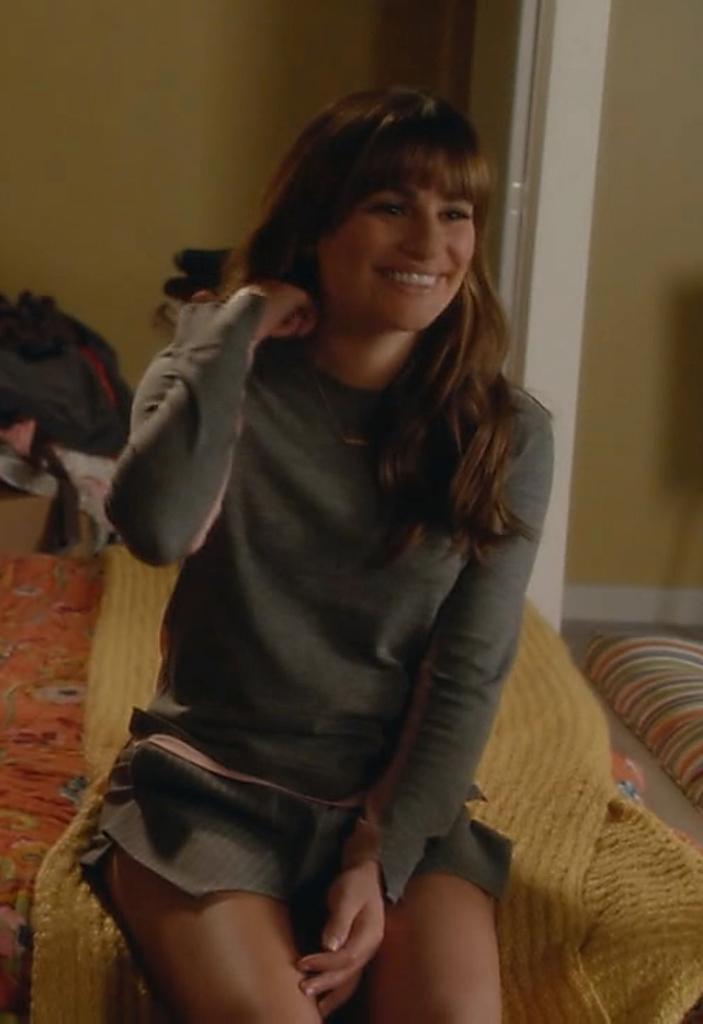Describe this image in one or two sentences. There is a woman in a skirt smiling and sitting on a bed which is covered with a bed sheet. In the background, there is a wall. 